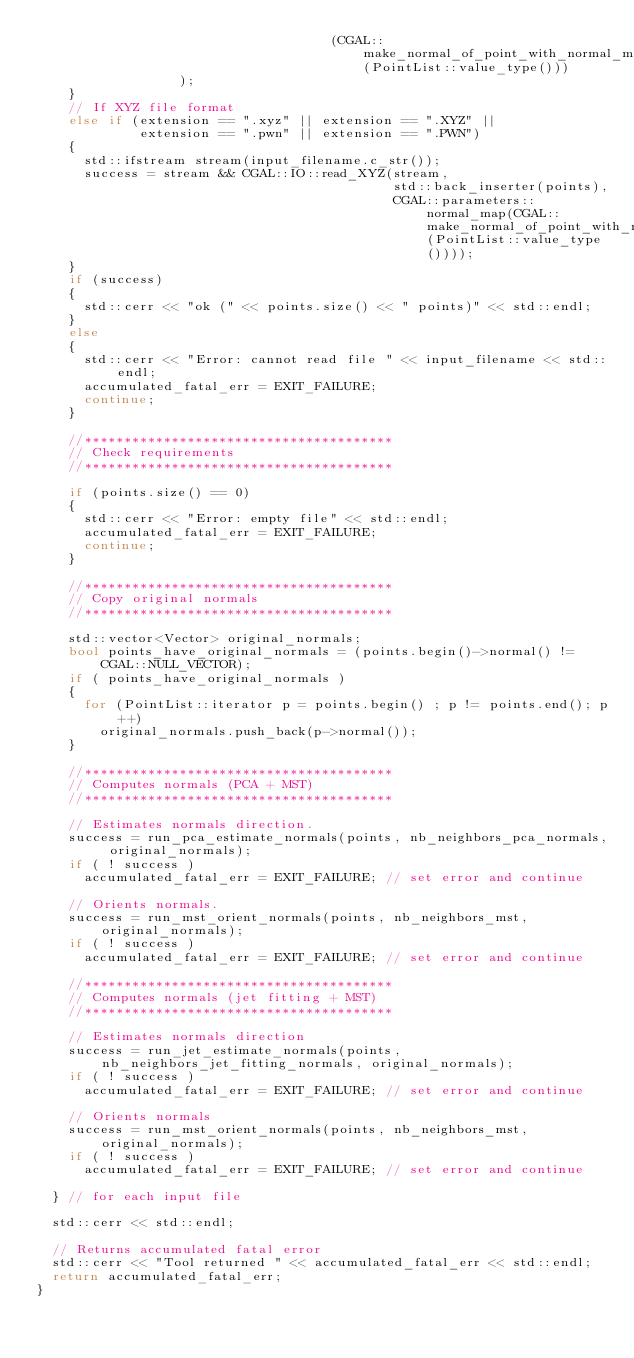<code> <loc_0><loc_0><loc_500><loc_500><_C++_>                                     (CGAL::make_normal_of_point_with_normal_map(PointList::value_type()))
                  );
    }
    // If XYZ file format
    else if (extension == ".xyz" || extension == ".XYZ" ||
             extension == ".pwn" || extension == ".PWN")
    {
      std::ifstream stream(input_filename.c_str());
      success = stream && CGAL::IO::read_XYZ(stream,
                                             std::back_inserter(points),
                                             CGAL::parameters::normal_map(CGAL::make_normal_of_point_with_normal_map(PointList::value_type())));
    }
    if (success)
    {
      std::cerr << "ok (" << points.size() << " points)" << std::endl;
    }
    else
    {
      std::cerr << "Error: cannot read file " << input_filename << std::endl;
      accumulated_fatal_err = EXIT_FAILURE;
      continue;
    }

    //***************************************
    // Check requirements
    //***************************************

    if (points.size() == 0)
    {
      std::cerr << "Error: empty file" << std::endl;
      accumulated_fatal_err = EXIT_FAILURE;
      continue;
    }

    //***************************************
    // Copy original normals
    //***************************************

    std::vector<Vector> original_normals;
    bool points_have_original_normals = (points.begin()->normal() != CGAL::NULL_VECTOR);
    if ( points_have_original_normals )
    {
      for (PointList::iterator p = points.begin() ; p != points.end(); p++)
        original_normals.push_back(p->normal());
    }

    //***************************************
    // Computes normals (PCA + MST)
    //***************************************

    // Estimates normals direction.
    success = run_pca_estimate_normals(points, nb_neighbors_pca_normals, original_normals);
    if ( ! success )
      accumulated_fatal_err = EXIT_FAILURE; // set error and continue

    // Orients normals.
    success = run_mst_orient_normals(points, nb_neighbors_mst, original_normals);
    if ( ! success )
      accumulated_fatal_err = EXIT_FAILURE; // set error and continue

    //***************************************
    // Computes normals (jet fitting + MST)
    //***************************************

    // Estimates normals direction
    success = run_jet_estimate_normals(points, nb_neighbors_jet_fitting_normals, original_normals);
    if ( ! success )
      accumulated_fatal_err = EXIT_FAILURE; // set error and continue

    // Orients normals
    success = run_mst_orient_normals(points, nb_neighbors_mst, original_normals);
    if ( ! success )
      accumulated_fatal_err = EXIT_FAILURE; // set error and continue

  } // for each input file

  std::cerr << std::endl;

  // Returns accumulated fatal error
  std::cerr << "Tool returned " << accumulated_fatal_err << std::endl;
  return accumulated_fatal_err;
}
</code> 